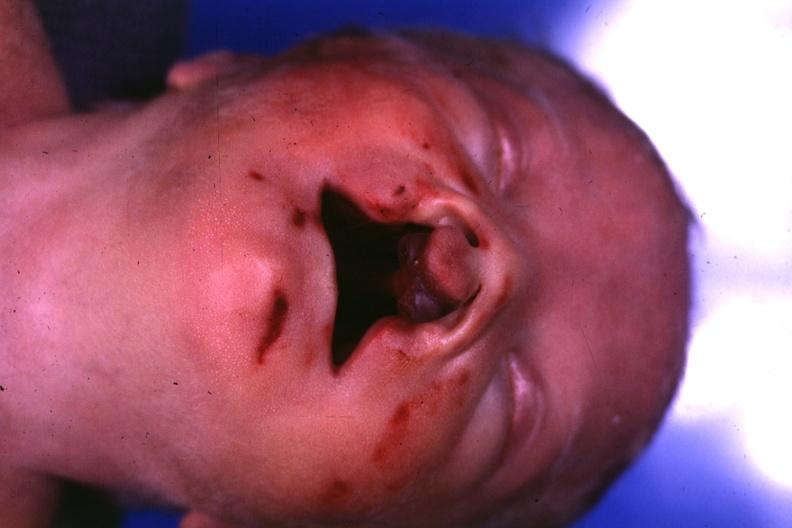what is present?
Answer the question using a single word or phrase. Bilateral cleft palate 